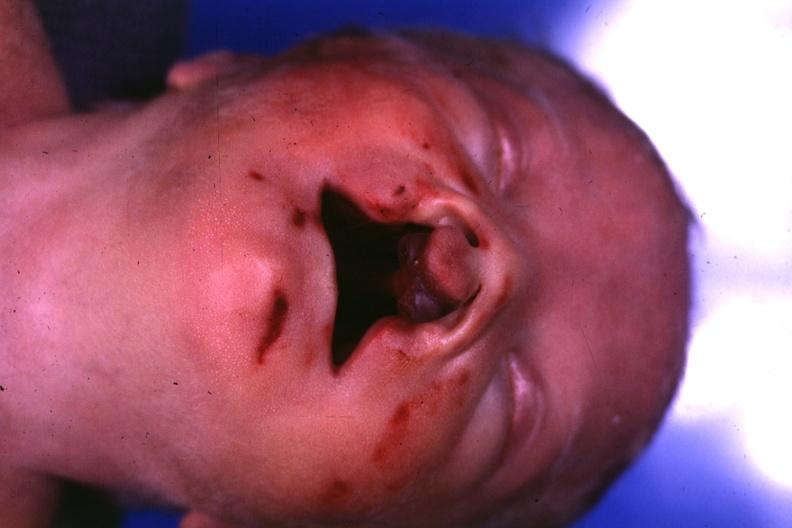what is present?
Answer the question using a single word or phrase. Bilateral cleft palate 